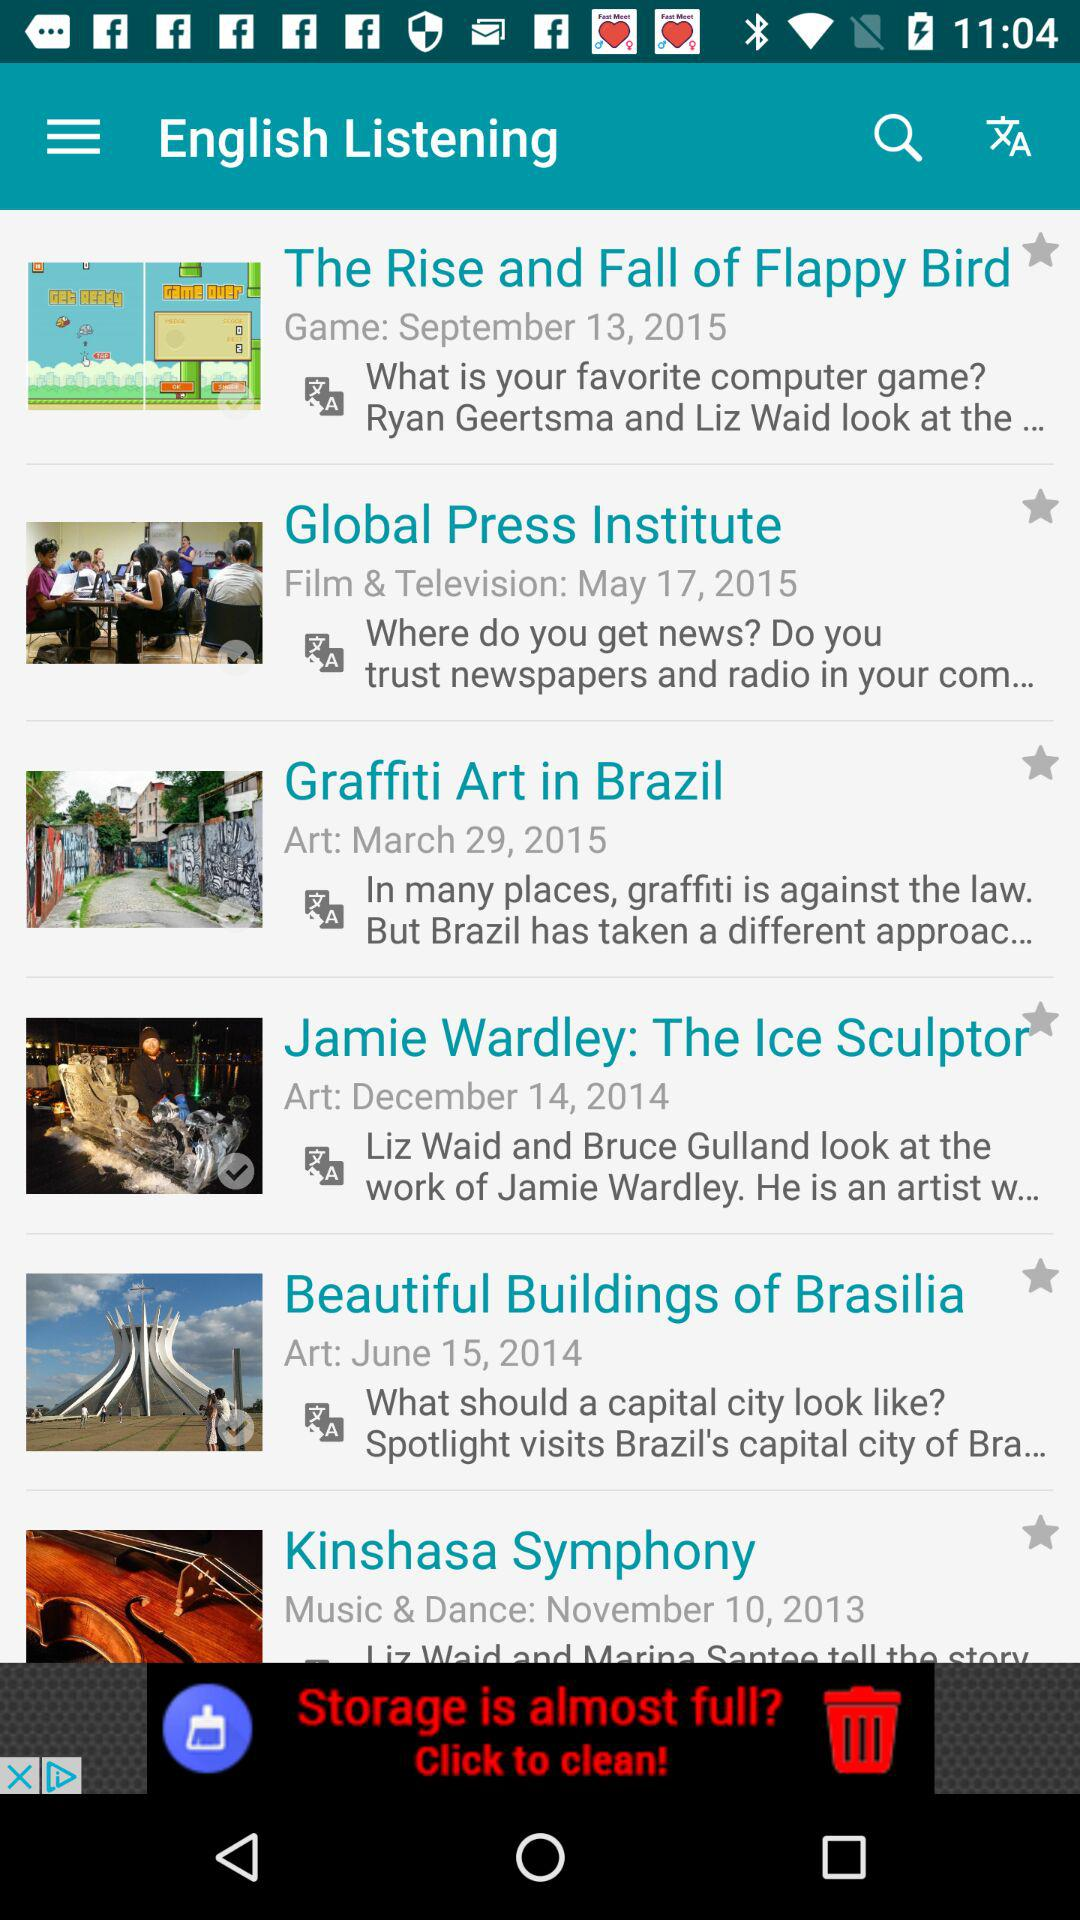What date is shown in "Graffiti Art in Brazil"? The shown date in "Graffiti Art in Brazil" is 29th March, 2015. 